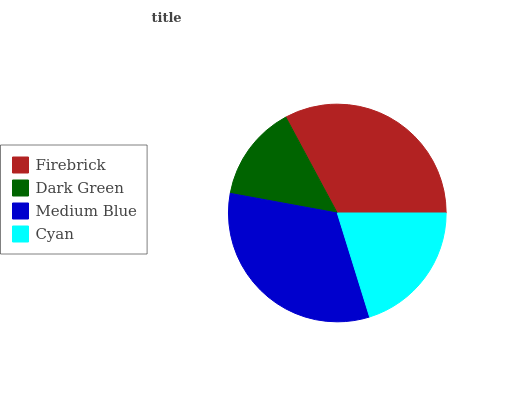Is Dark Green the minimum?
Answer yes or no. Yes. Is Firebrick the maximum?
Answer yes or no. Yes. Is Medium Blue the minimum?
Answer yes or no. No. Is Medium Blue the maximum?
Answer yes or no. No. Is Medium Blue greater than Dark Green?
Answer yes or no. Yes. Is Dark Green less than Medium Blue?
Answer yes or no. Yes. Is Dark Green greater than Medium Blue?
Answer yes or no. No. Is Medium Blue less than Dark Green?
Answer yes or no. No. Is Medium Blue the high median?
Answer yes or no. Yes. Is Cyan the low median?
Answer yes or no. Yes. Is Dark Green the high median?
Answer yes or no. No. Is Firebrick the low median?
Answer yes or no. No. 